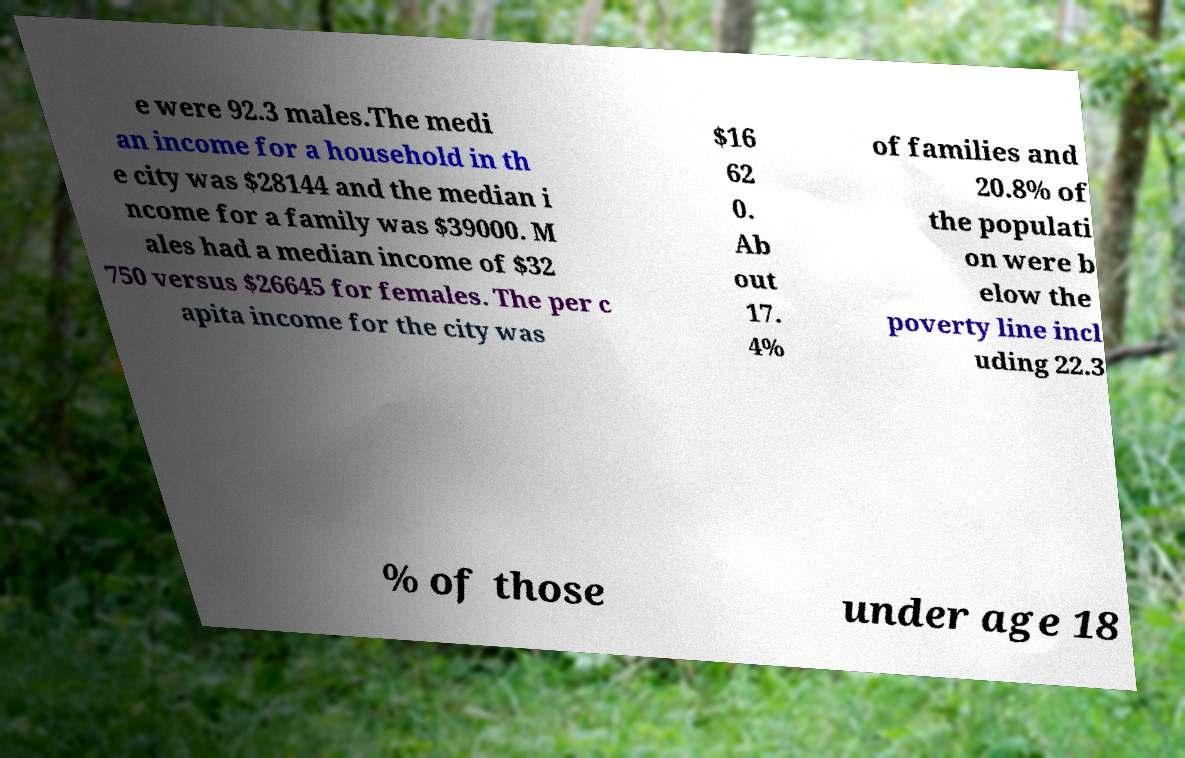What messages or text are displayed in this image? I need them in a readable, typed format. e were 92.3 males.The medi an income for a household in th e city was $28144 and the median i ncome for a family was $39000. M ales had a median income of $32 750 versus $26645 for females. The per c apita income for the city was $16 62 0. Ab out 17. 4% of families and 20.8% of the populati on were b elow the poverty line incl uding 22.3 % of those under age 18 